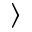<formula> <loc_0><loc_0><loc_500><loc_500>\rangle</formula> 